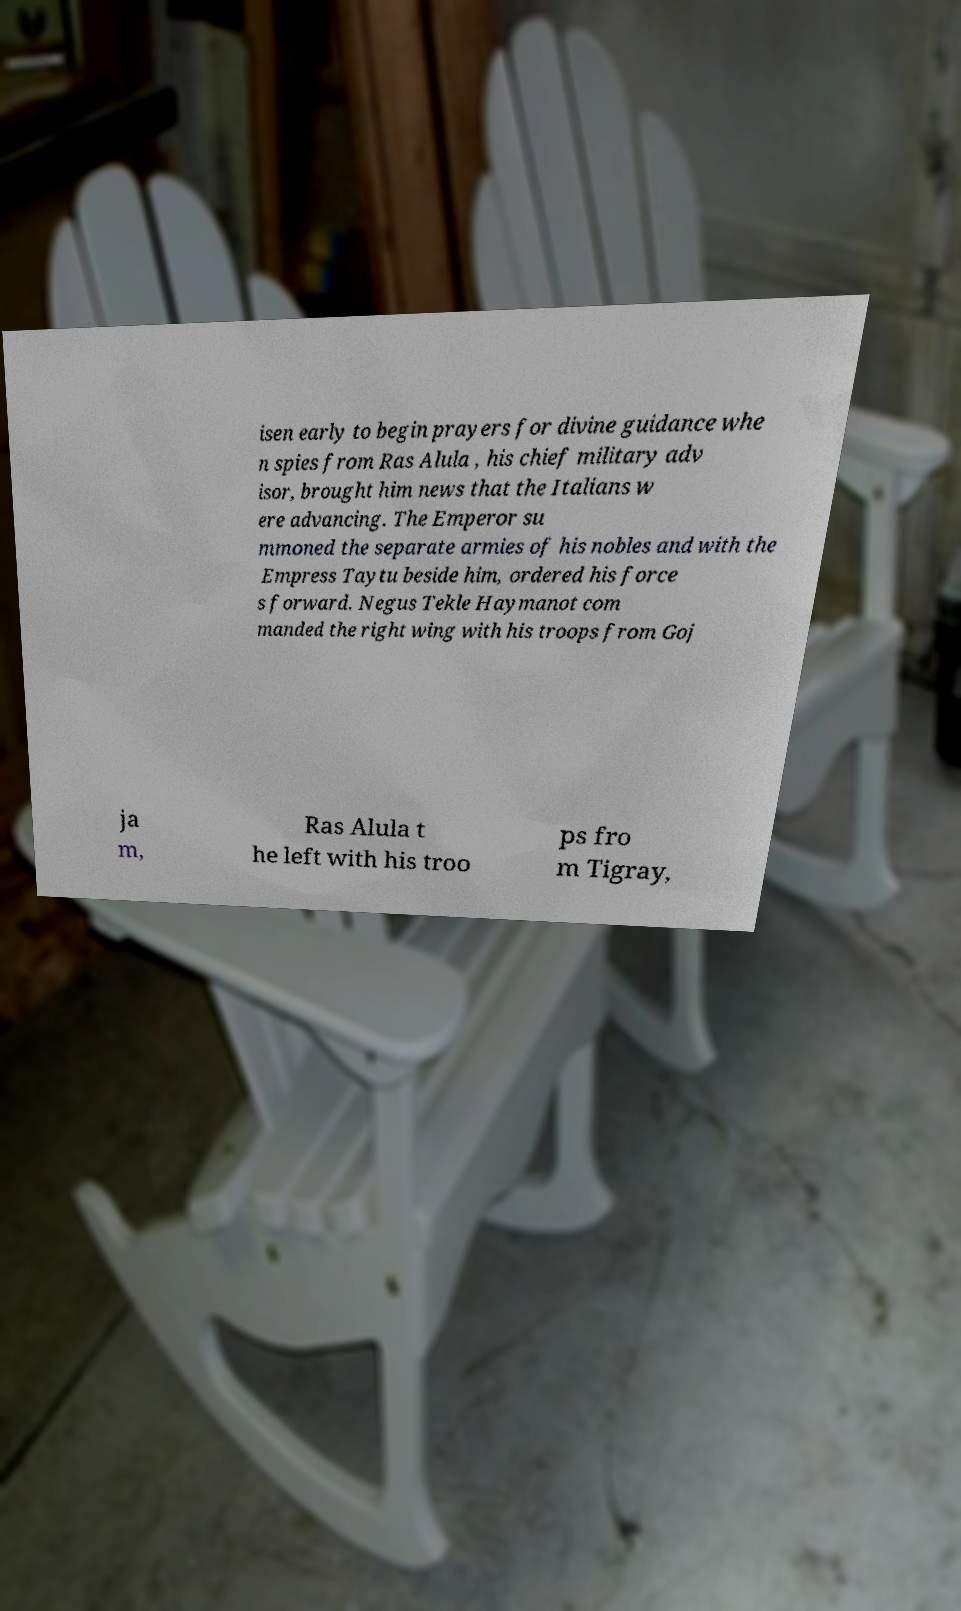For documentation purposes, I need the text within this image transcribed. Could you provide that? isen early to begin prayers for divine guidance whe n spies from Ras Alula , his chief military adv isor, brought him news that the Italians w ere advancing. The Emperor su mmoned the separate armies of his nobles and with the Empress Taytu beside him, ordered his force s forward. Negus Tekle Haymanot com manded the right wing with his troops from Goj ja m, Ras Alula t he left with his troo ps fro m Tigray, 